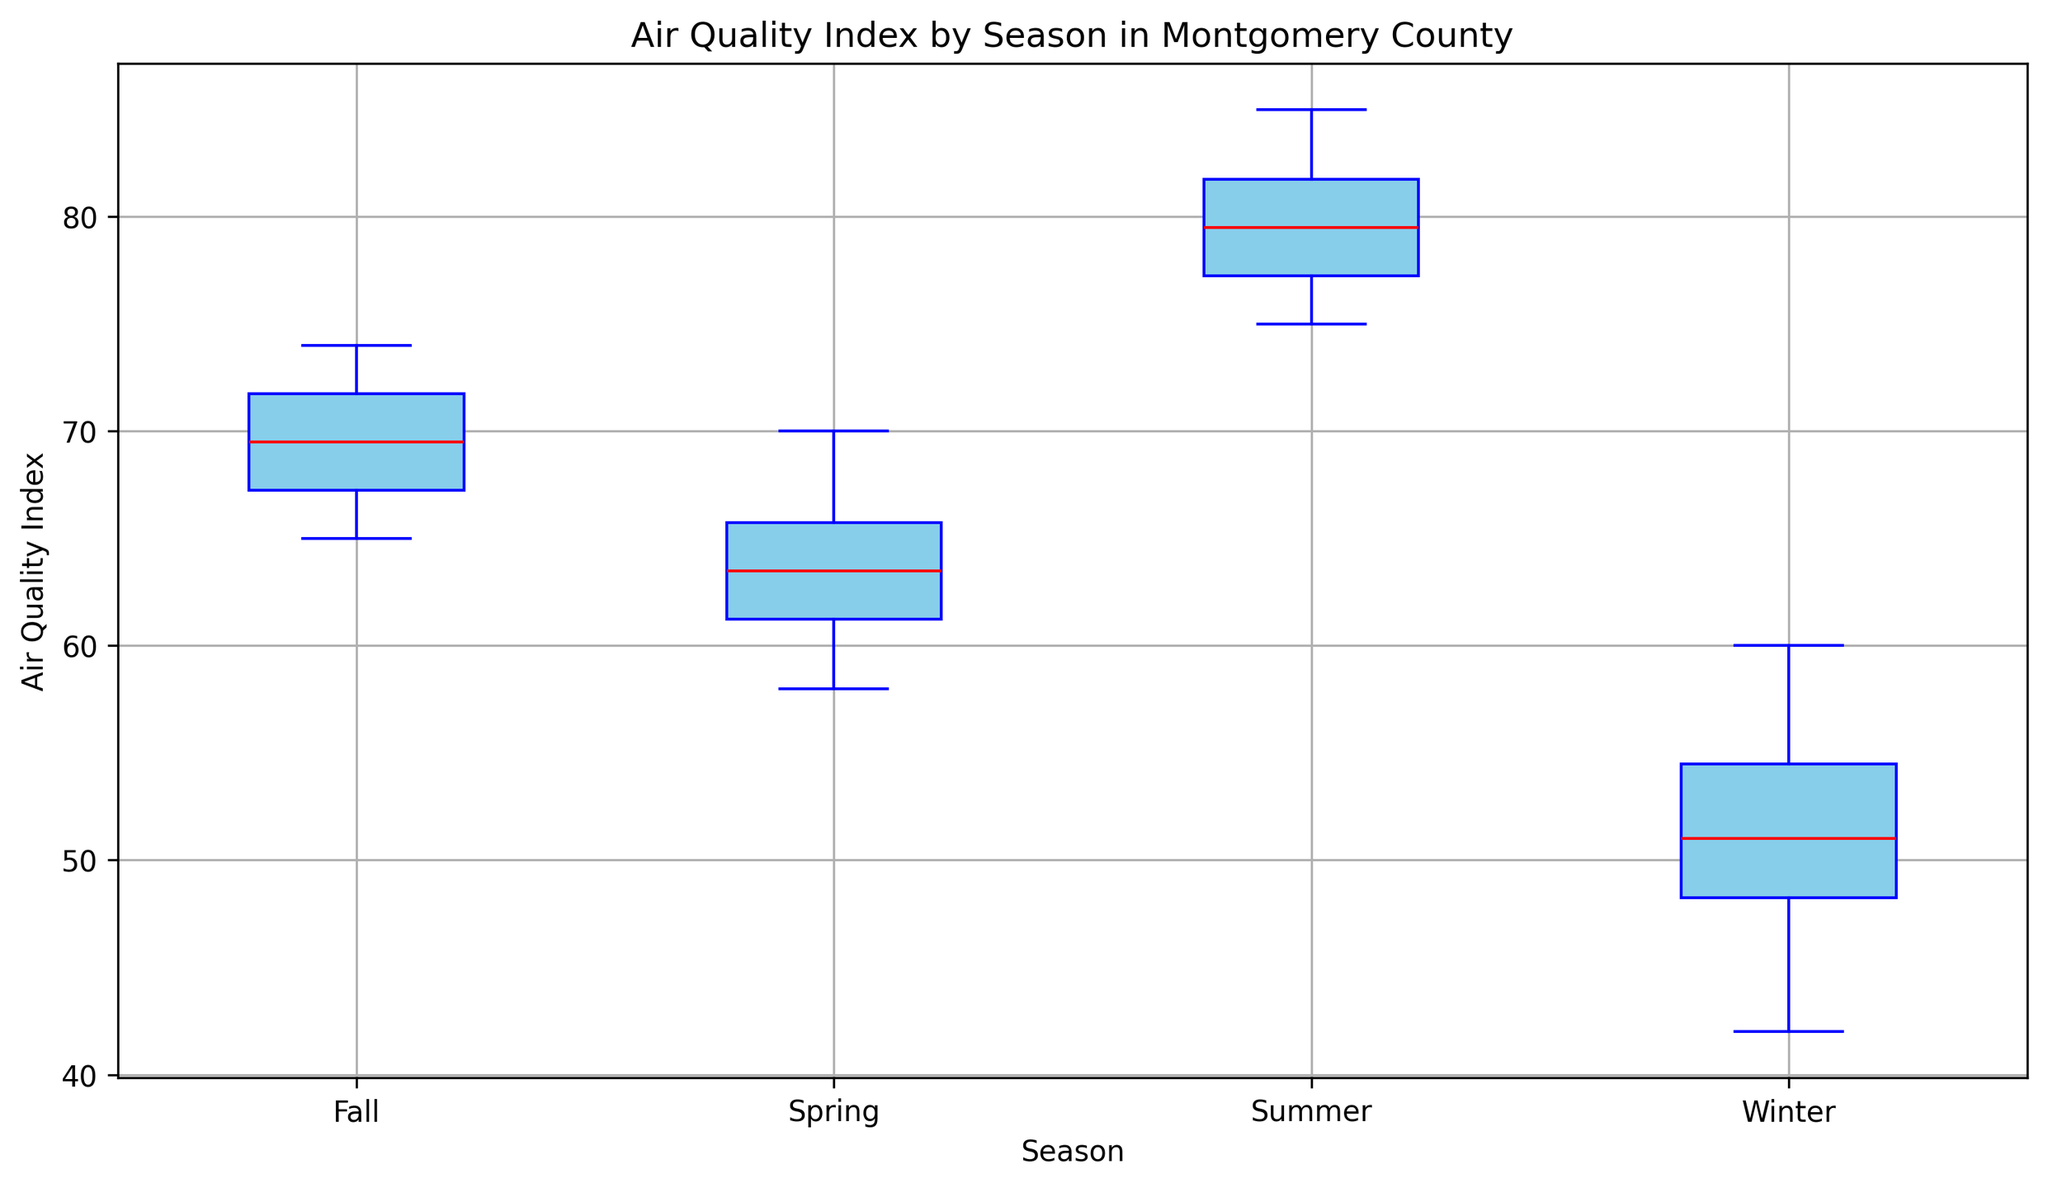Which season has the highest median Air Quality Index? The box plot shows the median value as a red line within each box. By comparing the median lines, Summer has the highest median Air Quality Index.
Answer: Summer Which season has the lowest median Air Quality Index? The red line within each box represents the median value. Comparing these lines, Winter has the lowest median Air Quality Index.
Answer: Winter What's the interquartile range (IQR) of the Air Quality Index in Spring? The IQR is the difference between the third quartile (Q3) and the first quartile (Q1). In the box plot, the top and bottom edges of the box represent Q3 and Q1 respectively. For Spring, approximate Q3 is 66 and Q1 is 61, so IQR = 66 - 61 = 5.
Answer: 5 Which season has the widest range in Air Quality Index? The range is the distance between the top and bottom whiskers. By comparing the whiskers across seasons, Summer has the widest range.
Answer: Summer Is the Air Quality Index more variable in Winter or Fall? Variability can be assessed by looking at the length of the box and the whiskers. Winter has shorter boxes and whiskers compared to Fall, indicating less variability. Therefore, Fall has more variability in the Air Quality Index.
Answer: Fall Which season has the highest maximum Air Quality Index? The maximum value is indicated by the top whisker. By comparing the positions of the top whiskers, Summer has the highest maximum Air Quality Index at around 85.
Answer: Summer In which season do we observe outliers in the Air Quality Index? Outliers are represented by green dots beyond the whiskers. By looking at the plot, there are no green dots, indicating no outliers in any season.
Answer: None How does the median Air Quality Index in Fall compare to that in Summer? The median values are represented by the red lines in each box. The median in Fall is lower than the median in Summer.
Answer: Lower Which season has the narrowest interquartile range (IQR) in Air Quality Index? The IQR is the width of the box. By looking at the box widths, Fall has the narrowest interquartile range.
Answer: Fall What is the approximate difference between the maximum Air Quality Index in Summer and Winter? The maximum value is indicated by the top whisker. The approximate maximum values for Summer and Winter are 85 and 60 respectively, so the difference is 85 - 60 = 25.
Answer: 25 